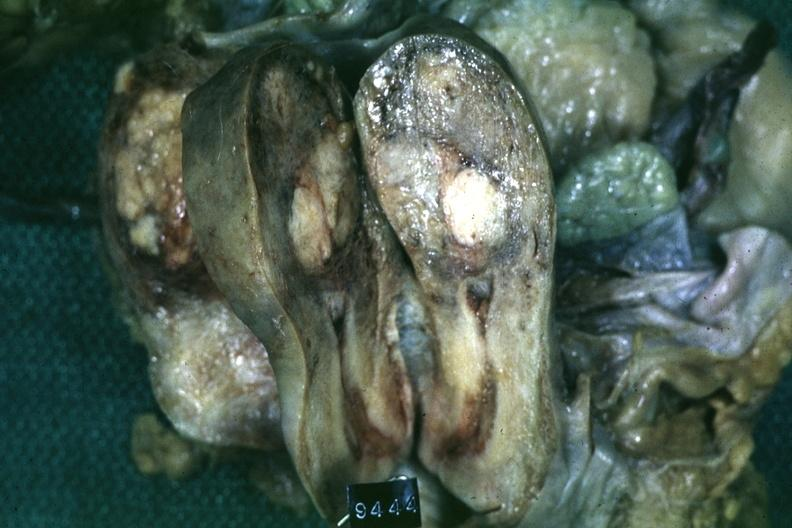s simian crease present?
Answer the question using a single word or phrase. No 